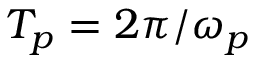Convert formula to latex. <formula><loc_0><loc_0><loc_500><loc_500>T _ { p } = 2 \pi / \omega _ { p }</formula> 